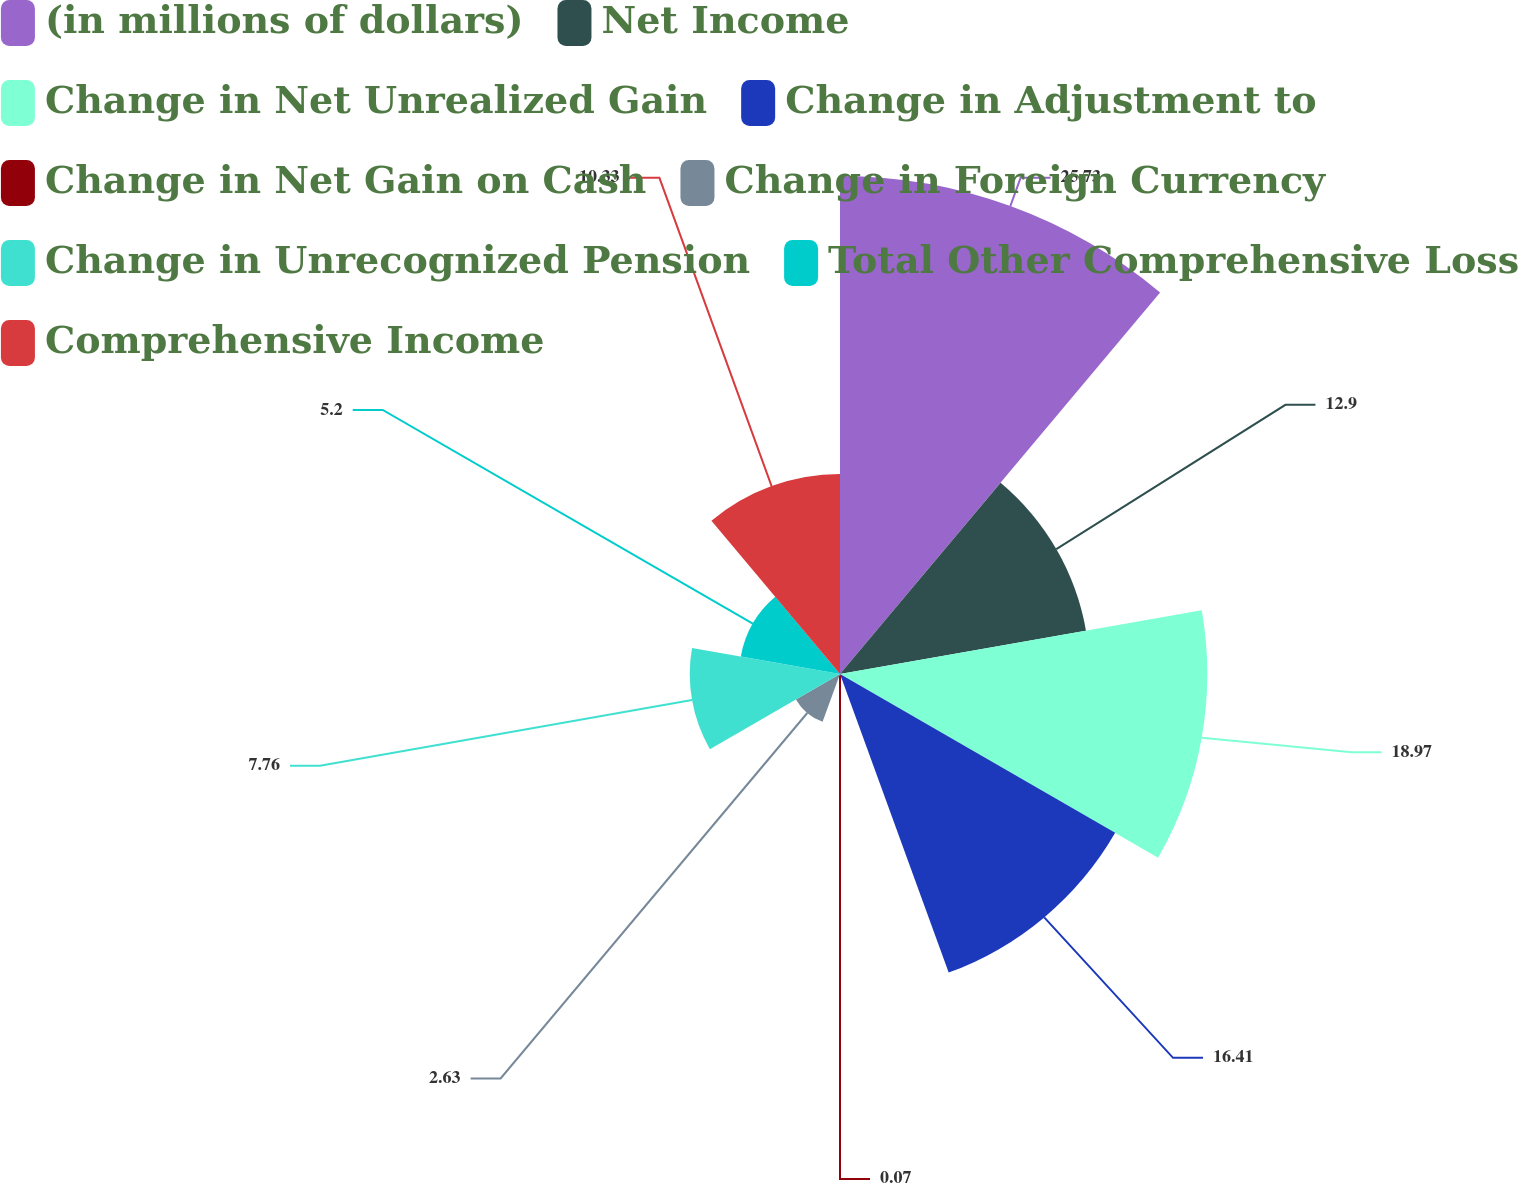Convert chart. <chart><loc_0><loc_0><loc_500><loc_500><pie_chart><fcel>(in millions of dollars)<fcel>Net Income<fcel>Change in Net Unrealized Gain<fcel>Change in Adjustment to<fcel>Change in Net Gain on Cash<fcel>Change in Foreign Currency<fcel>Change in Unrecognized Pension<fcel>Total Other Comprehensive Loss<fcel>Comprehensive Income<nl><fcel>25.72%<fcel>12.9%<fcel>18.97%<fcel>16.41%<fcel>0.07%<fcel>2.63%<fcel>7.76%<fcel>5.2%<fcel>10.33%<nl></chart> 